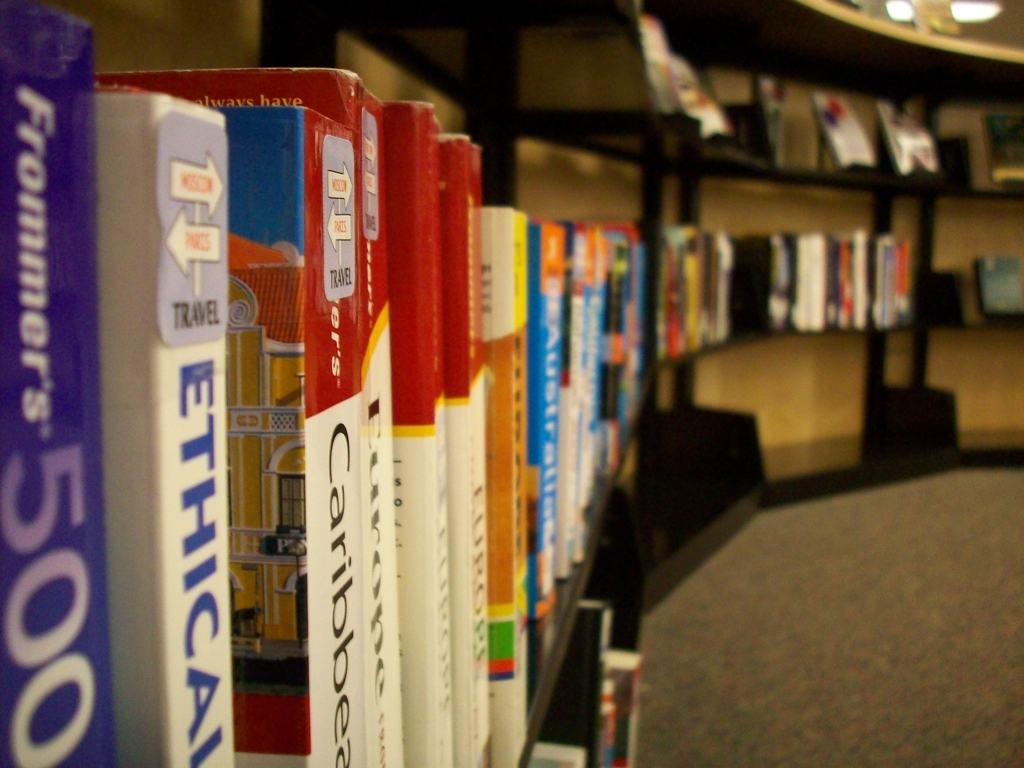Can most of the texture details of the subject be identified? Indeed, most texture details are clearly visible. The books' spines exhibit distinguishable textures, each conveying the cover's material quality — some appear smooth and glossy, seemingly laminated, while others show a more matte and coarse finish. Text and logos are sharp enough to suggest a quality reading experience. 